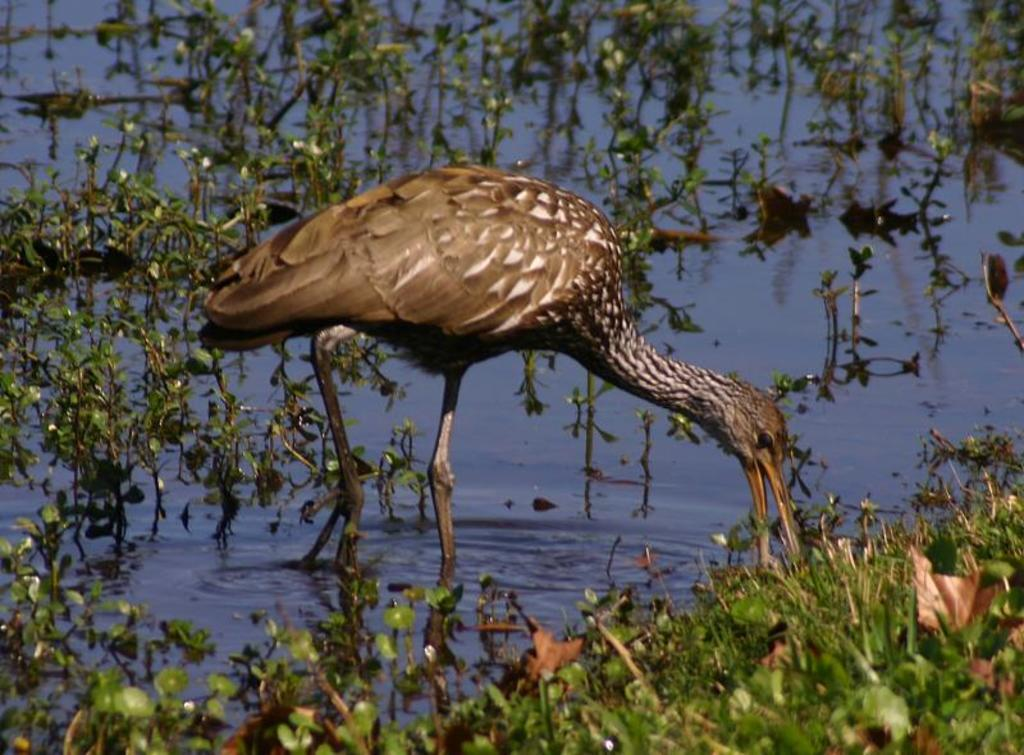What is located at the bottom of the image? There are many plants on the water at the bottom of the image. What can be seen in the middle of the water? There is a brown crane in the middle of the water. What is the crane doing in the image? The crane is standing and eating the plants. Where is the market located in the image? There is no market present in the image. Is the crane riding a bike in the image? No, the crane is standing and eating the plants, and there is no bike present in the image. 